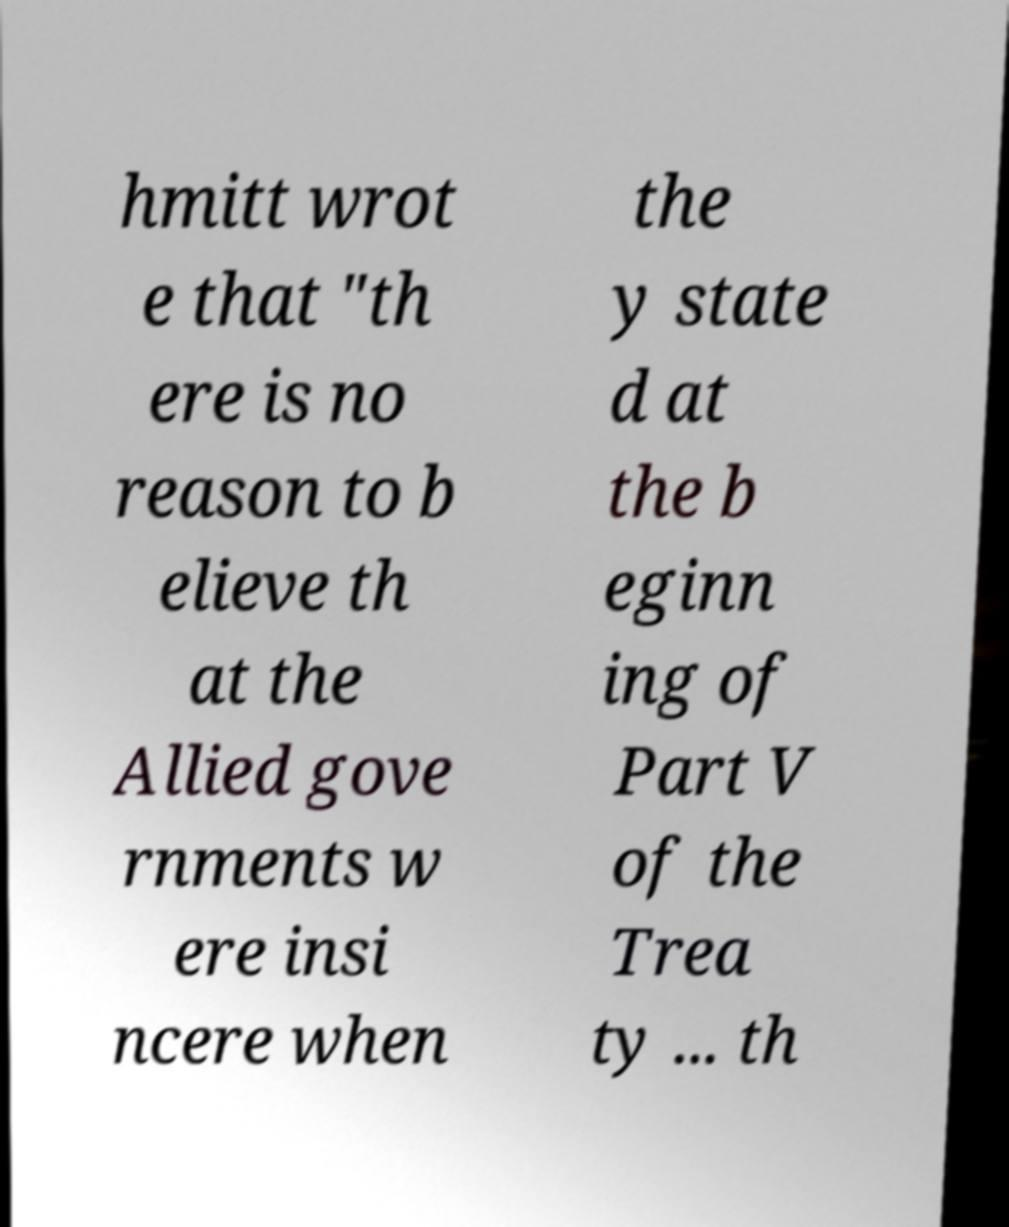Can you read and provide the text displayed in the image?This photo seems to have some interesting text. Can you extract and type it out for me? hmitt wrot e that "th ere is no reason to b elieve th at the Allied gove rnments w ere insi ncere when the y state d at the b eginn ing of Part V of the Trea ty ... th 